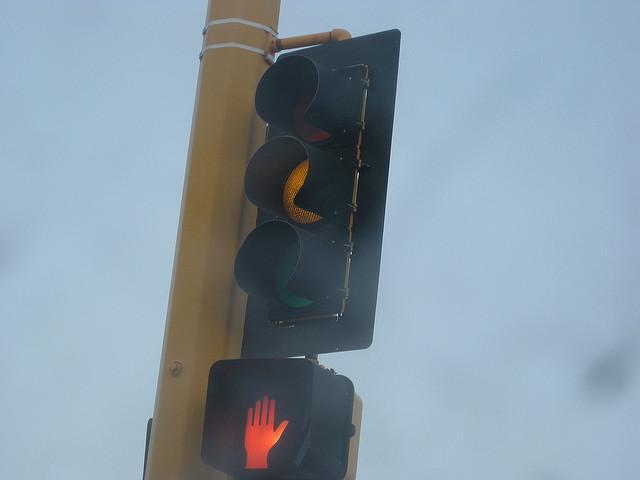How many traffic lights are visible?
Give a very brief answer. 2. How many motorcycles have a helmet on the handle bars?
Give a very brief answer. 0. 